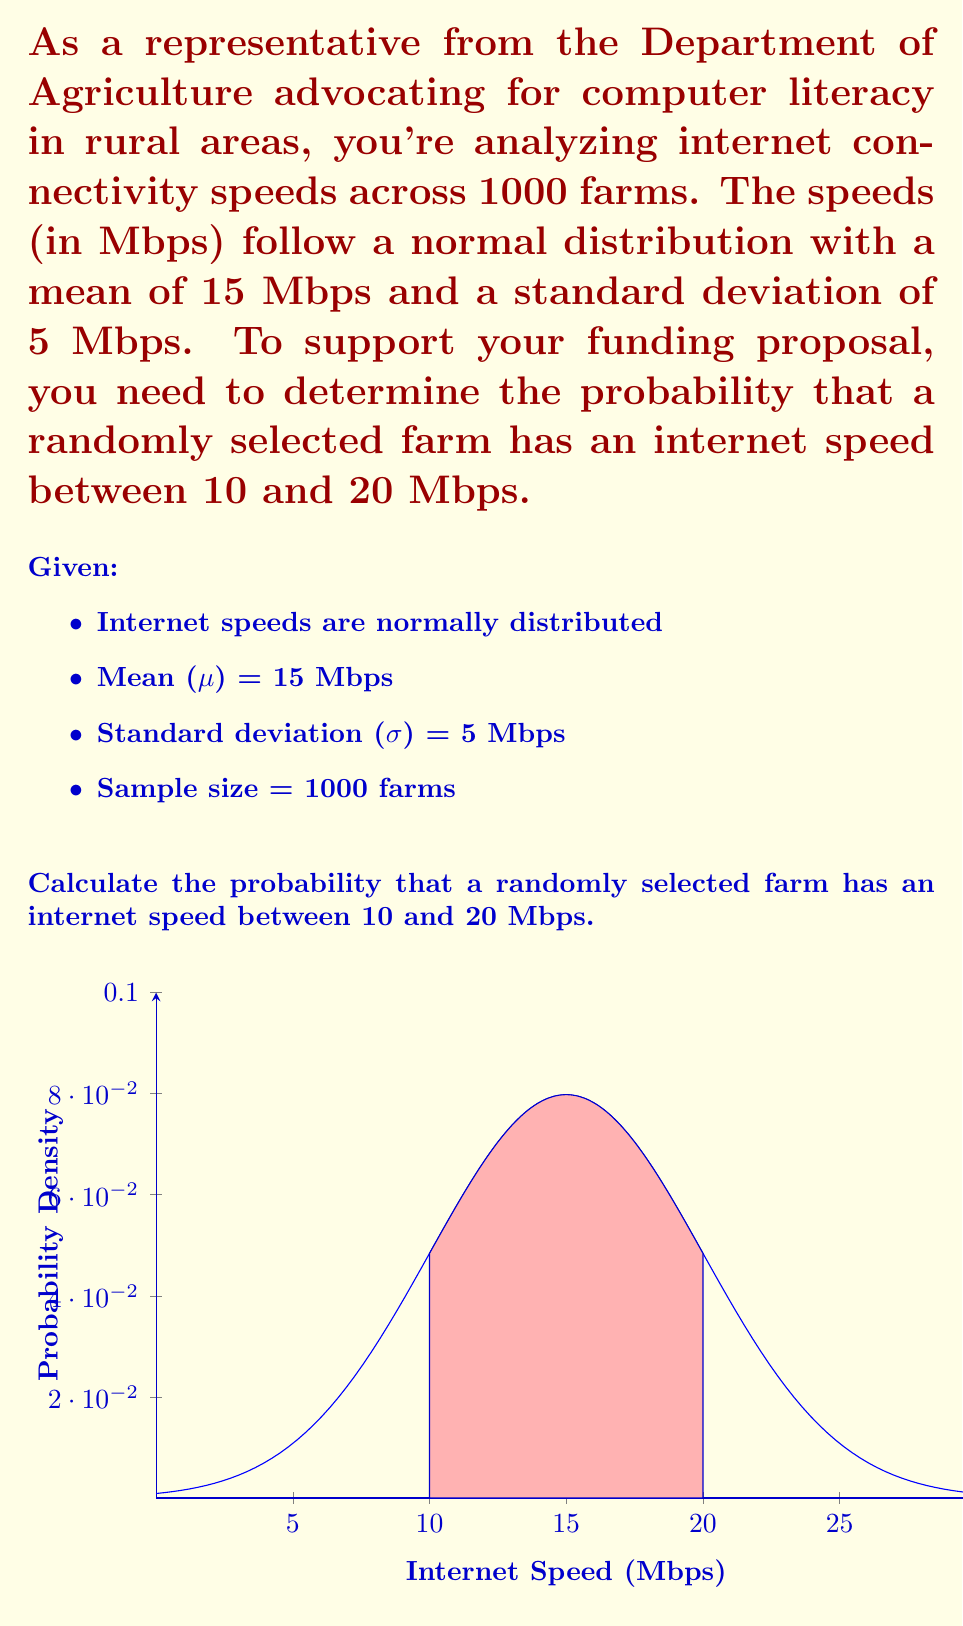Give your solution to this math problem. To solve this problem, we'll use the standard normal distribution (z-score) approach:

1) First, we need to calculate the z-scores for the given speeds:

   For 10 Mbps: $z_1 = \frac{x - \mu}{\sigma} = \frac{10 - 15}{5} = -1$
   For 20 Mbps: $z_2 = \frac{x - \mu}{\sigma} = \frac{20 - 15}{5} = 1$

2) Now, we need to find the area under the standard normal curve between these two z-scores.

3) Using a standard normal distribution table or calculator:
   P(Z < 1) = 0.8413
   P(Z < -1) = 0.1587

4) The probability we're looking for is the difference between these two:
   P(-1 < Z < 1) = P(Z < 1) - P(Z < -1)
                 = 0.8413 - 0.1587
                 = 0.6826

5) Therefore, the probability that a randomly selected farm has an internet speed between 10 and 20 Mbps is approximately 0.6826 or 68.26%.

This result suggests that about 68.26% of the farms in your sample have internet speeds between 10 and 20 Mbps, which could be a strong point in your funding proposal for improving internet connectivity in rural areas.
Answer: 0.6826 or 68.26% 